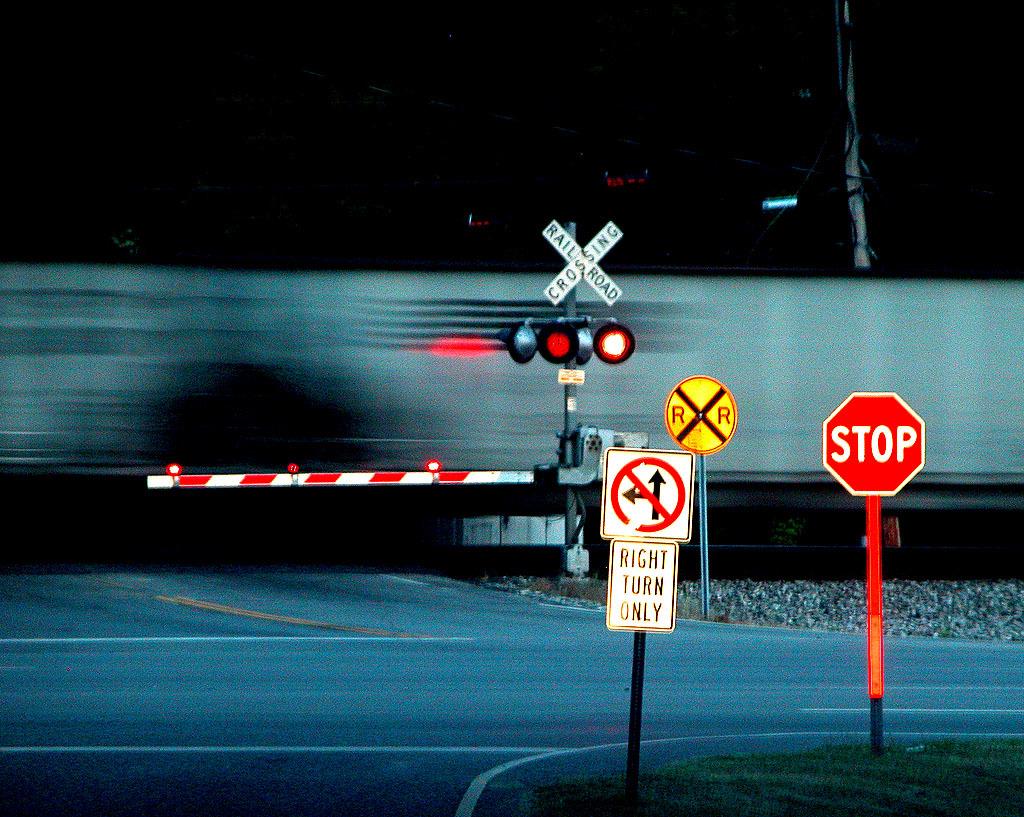Whats the sign warning?
Make the answer very short. Right turn only. 